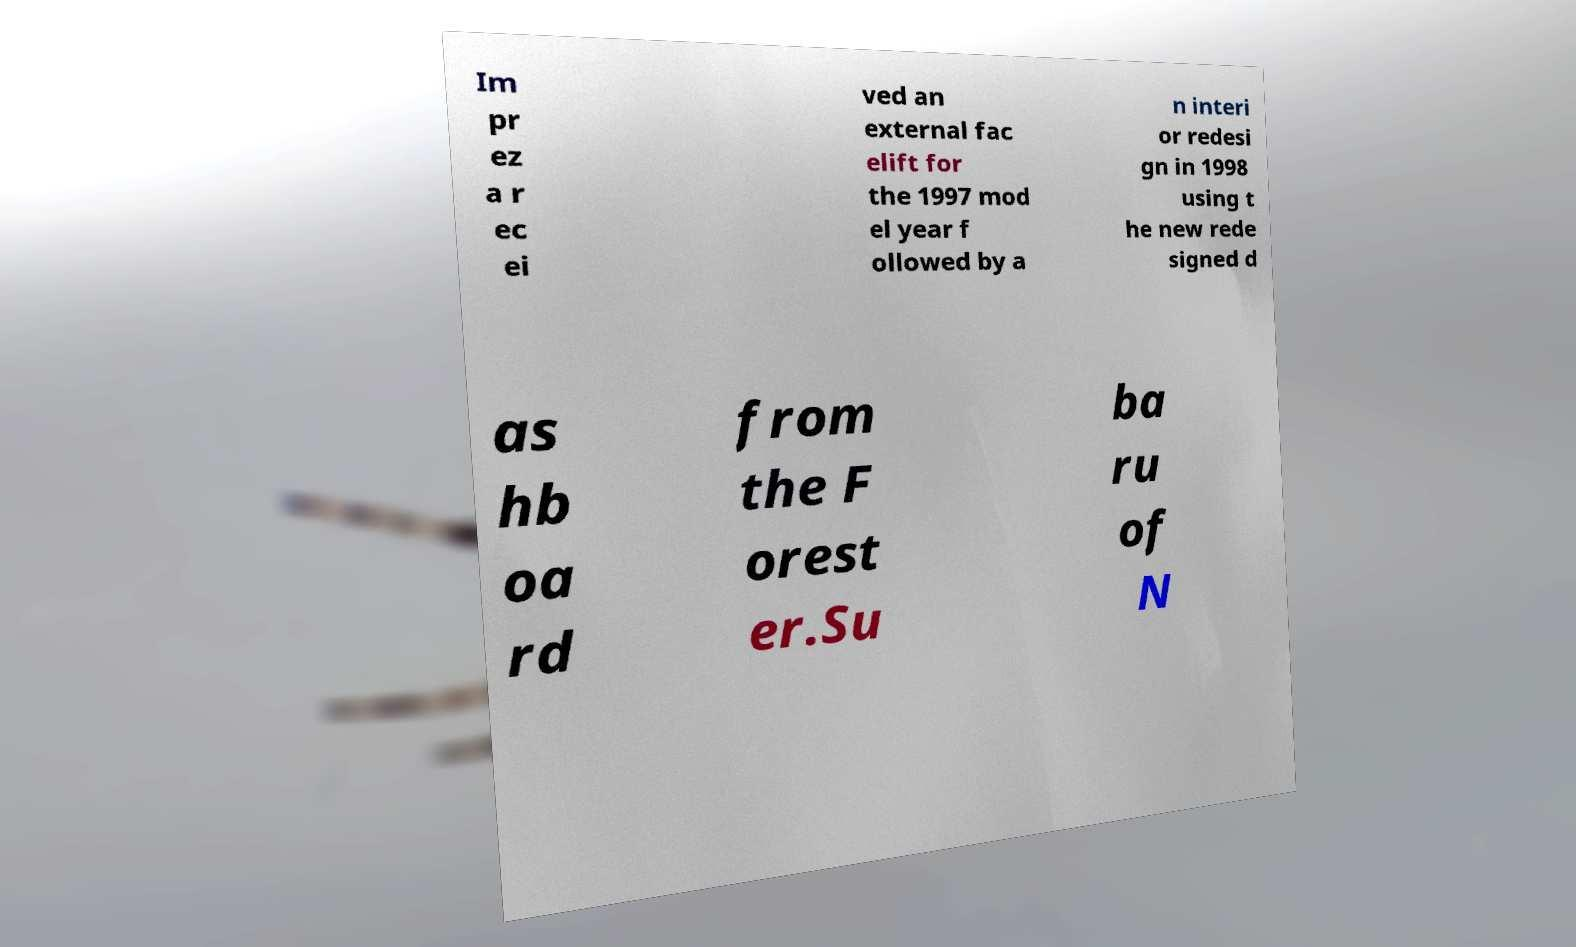For documentation purposes, I need the text within this image transcribed. Could you provide that? Im pr ez a r ec ei ved an external fac elift for the 1997 mod el year f ollowed by a n interi or redesi gn in 1998 using t he new rede signed d as hb oa rd from the F orest er.Su ba ru of N 